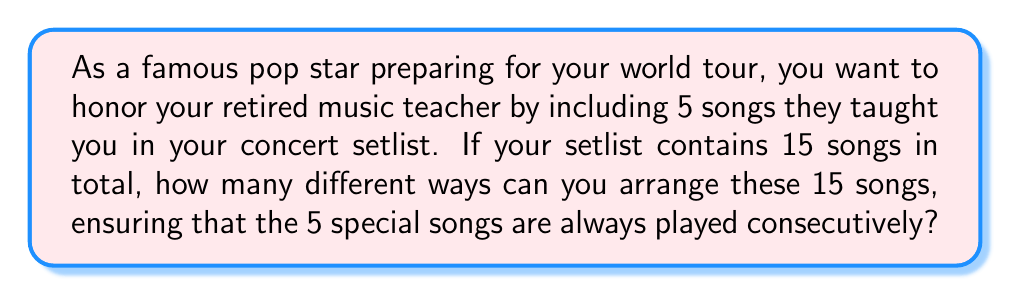Help me with this question. Let's approach this step-by-step:

1) First, we need to consider the 5 special songs as one unit. This means we essentially have 11 elements to arrange: the block of 5 special songs and the other 10 individual songs.

2) The number of ways to arrange 11 elements is simply 11!

3) However, we're not done yet. The 5 special songs within their block can also be arranged in different ways. This gives us an additional 5! arrangements.

4) By the multiplication principle, we multiply these two factors together.

5) Therefore, the total number of possible arrangements is:

   $$ 11! \times 5! $$

6) Let's calculate this:
   $$ 11! \times 5! = (39,916,800) \times (120) = 4,790,016,000 $$

This means there are 4,790,016,000 different ways to arrange the songs in your setlist while keeping the 5 special songs together.
Answer: 4,790,016,000 